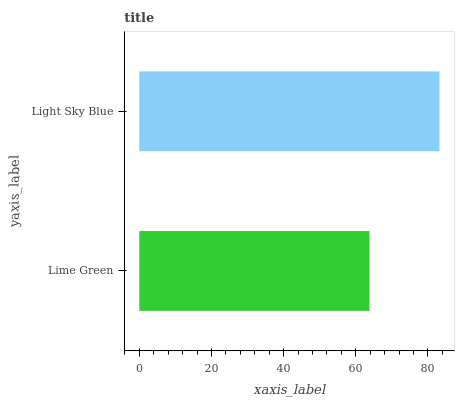Is Lime Green the minimum?
Answer yes or no. Yes. Is Light Sky Blue the maximum?
Answer yes or no. Yes. Is Light Sky Blue the minimum?
Answer yes or no. No. Is Light Sky Blue greater than Lime Green?
Answer yes or no. Yes. Is Lime Green less than Light Sky Blue?
Answer yes or no. Yes. Is Lime Green greater than Light Sky Blue?
Answer yes or no. No. Is Light Sky Blue less than Lime Green?
Answer yes or no. No. Is Light Sky Blue the high median?
Answer yes or no. Yes. Is Lime Green the low median?
Answer yes or no. Yes. Is Lime Green the high median?
Answer yes or no. No. Is Light Sky Blue the low median?
Answer yes or no. No. 